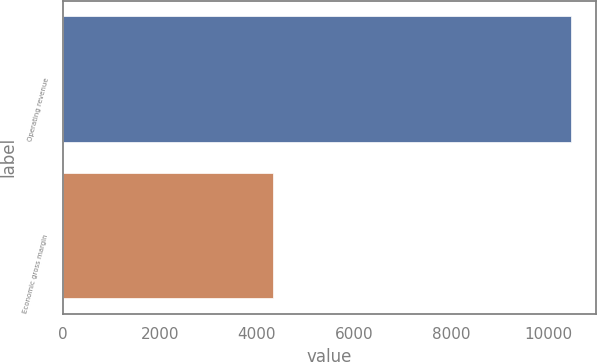Convert chart. <chart><loc_0><loc_0><loc_500><loc_500><bar_chart><fcel>Operating revenue<fcel>Economic gross margin<nl><fcel>10473<fcel>4334<nl></chart> 